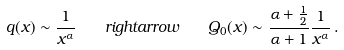<formula> <loc_0><loc_0><loc_500><loc_500>q ( x ) \sim \frac { 1 } { x ^ { \alpha } } \quad r i g h t a r r o w \quad Q _ { 0 } ( x ) \sim \frac { \alpha + \frac { 1 } { 2 } } { \alpha + 1 } \frac { 1 } { x ^ { \alpha } } \, .</formula> 